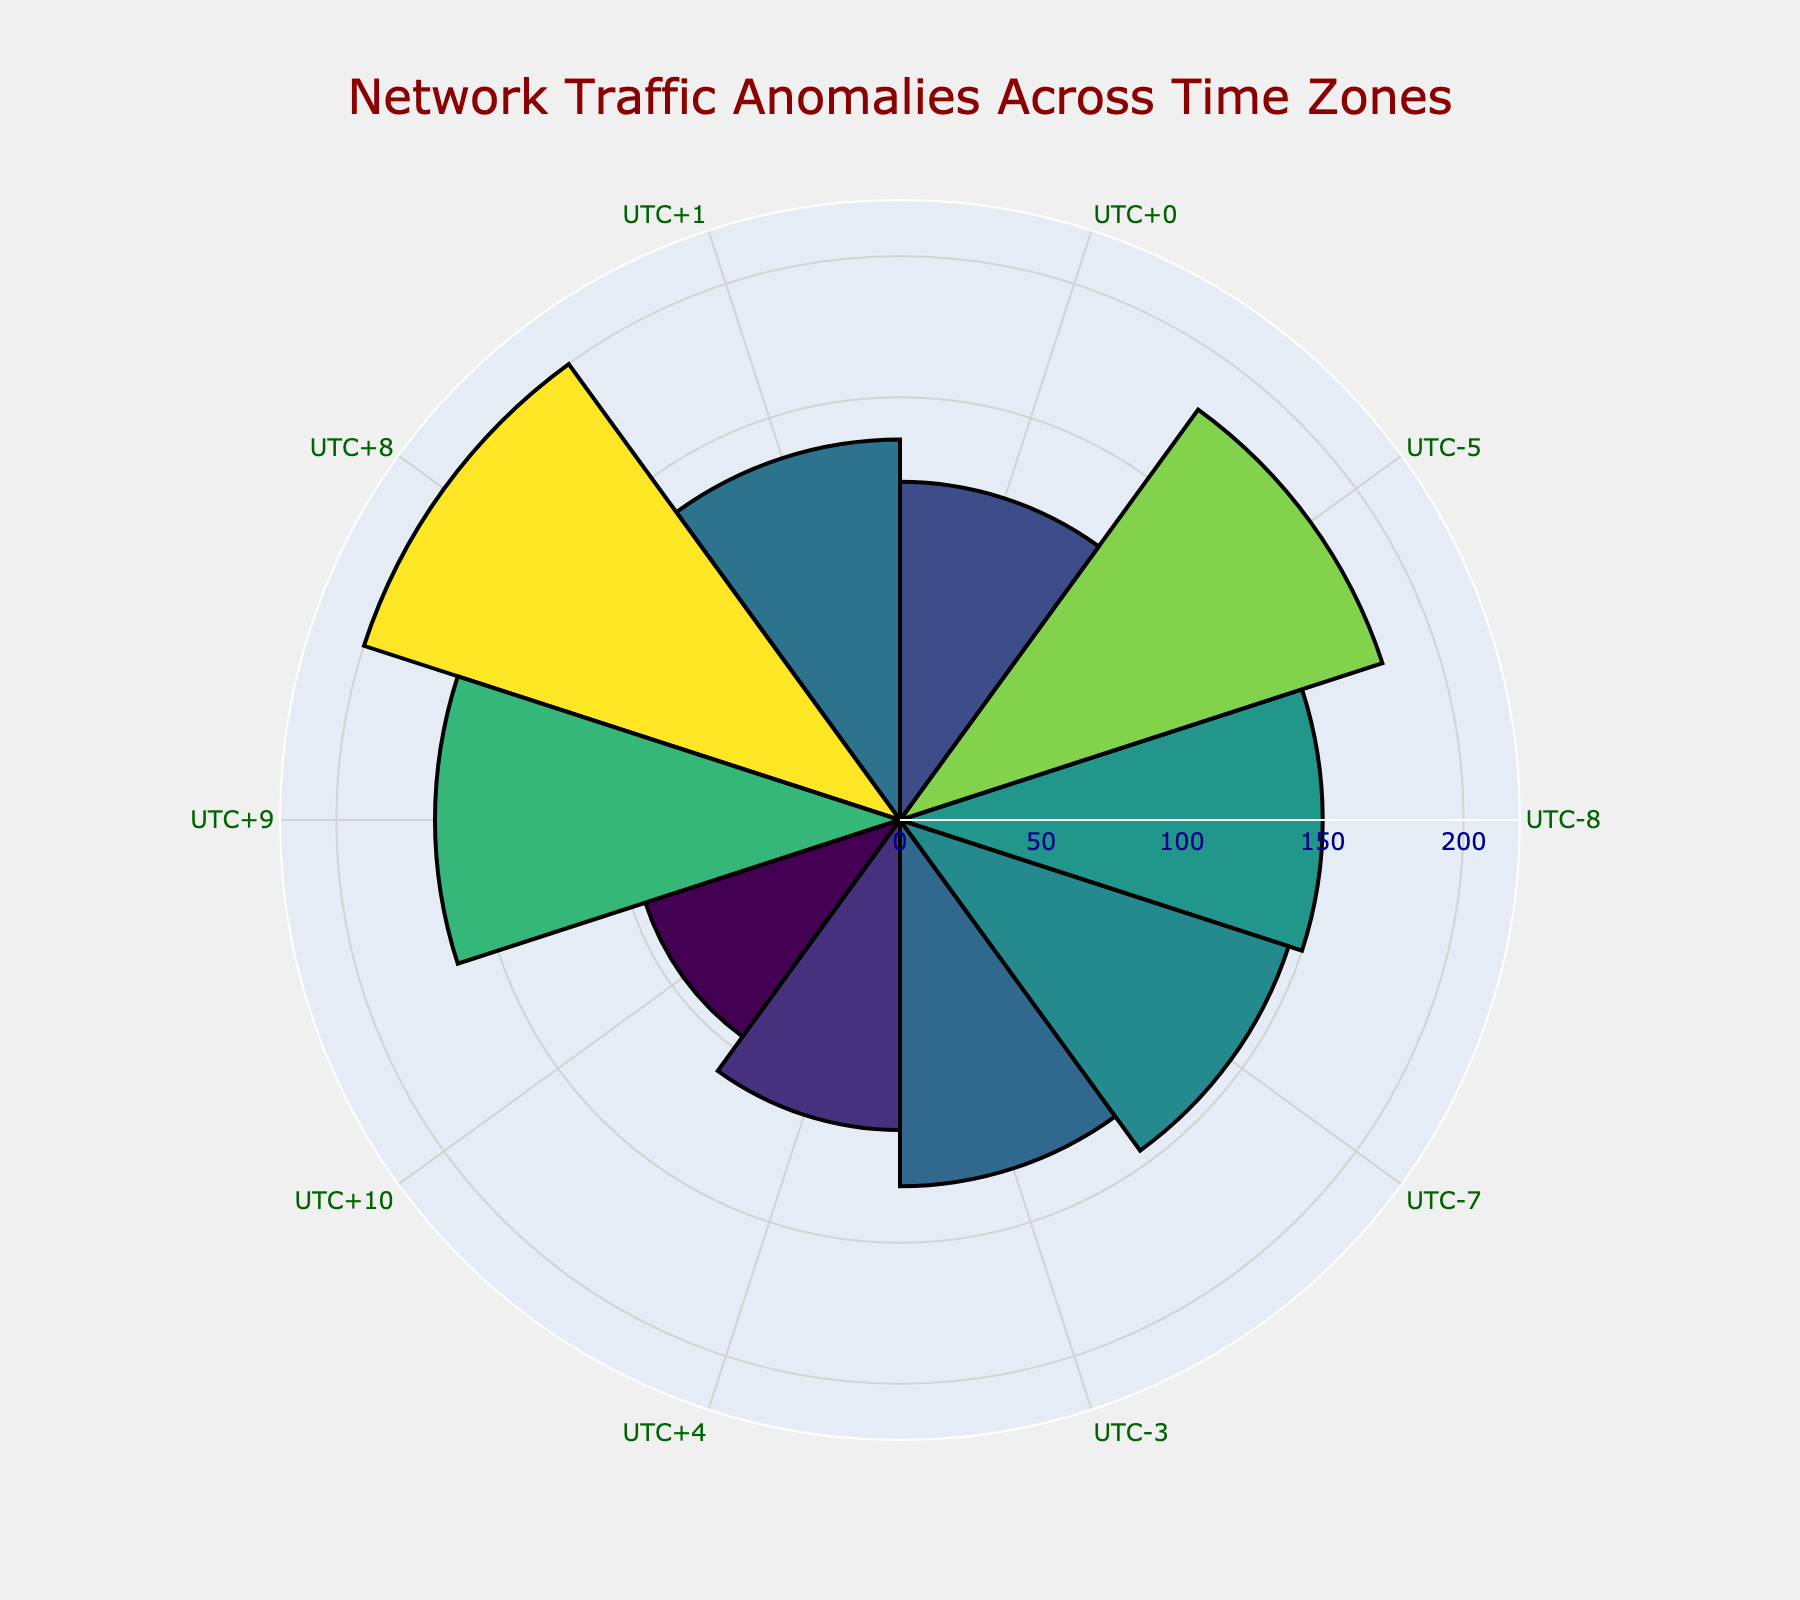what is the title of the figure? The title of the figure is often the largest text and typically located at the top, describing what the figure shows.
Answer: Network Traffic Anomalies Across Time Zones How many network traffic anomalies were reported for the University of California? Look at the bar representing the University of California (UTC-8). The hovertext will indicate the exact number of anomalies.
Answer: 150 Which time zone has the most network traffic anomalies? Compare the lengths of the bars across time zones. The longest bar indicates the highest number of anomalies.
Answer: UTC+8 What is the combined number of anomalies for universities in UTC-7 and UTC-3? Sum the anomalies for UTC-7 (University of Colorado) and UTC-3 (University of São Paulo).
Answer: 145 + 130 = 275 Which university has fewer anomalies: Sorbonne University or University of Sydney? Compare the bar lengths and hovertext for UTC+1 and UTC+10.
Answer: University of Sydney What is the average number of anomalies for UTC-8, UTC-5, and UTC+0 time zones? Sum the anomalies for each of these time zones and divide by the number of time zones. (150 + 180 + 120) / 3 = 150
Answer: 150 Which time zone has a similar number of anomalies as UTC+1? Identify the anomaly count for UTC+1 (135) and find another time zone with a close value.
Answer: UTC-7 (145) What is the highest recorded value of network traffic anomalies and which university does it belong to? Determine the maximum bar length and identify the corresponding hovertext showing the university name.
Answer: 200, National University of Singapore What is the difference in the number of anomalies between University of Tokyo and United Arab Emirates University? Calculate the difference in anomalies: 165 (UTC+9) - 110 (UTC+4).
Answer: 55 